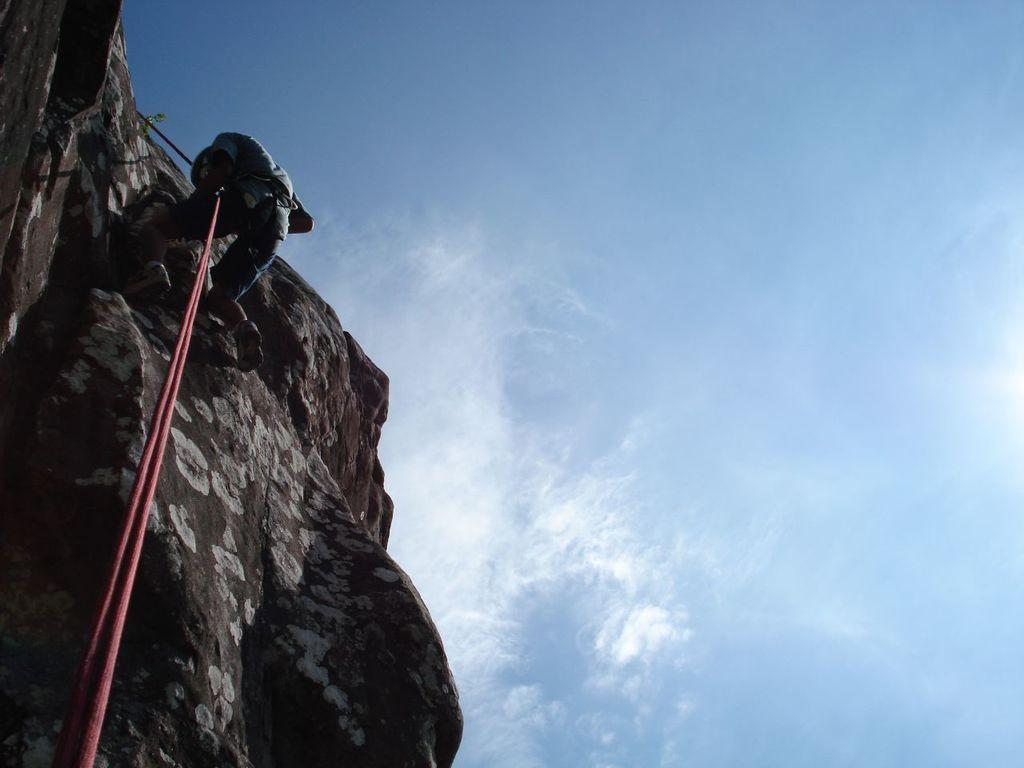What is the person in the image doing? The person is climbing a rock in the image. What is the person using to assist with the climb? The person is holding a rope. What color is the rope? The rope is red in color. What can be seen in the background of the image? The sky is blue and white in the background of the image. What type of trousers is the person wearing while reading in the image? There is no indication that the person is wearing trousers or reading in the image; they are climbing a rock while holding a red rope. 